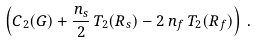Convert formula to latex. <formula><loc_0><loc_0><loc_500><loc_500>\left ( C _ { 2 } ( G ) + \frac { n _ { s } } { 2 } \, T _ { 2 } ( R _ { s } ) - 2 \, n _ { f } \, T _ { 2 } ( R _ { f } ) \right ) \, .</formula> 